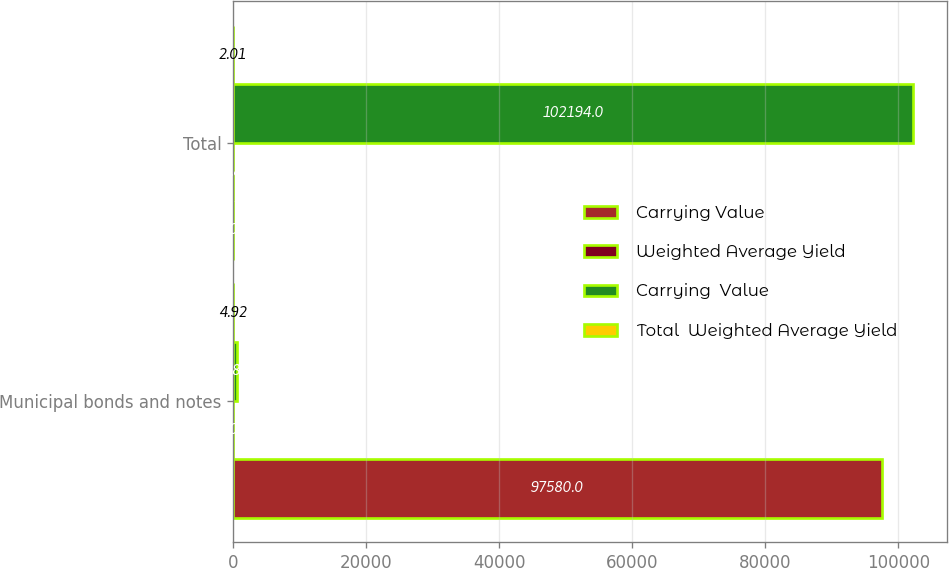Convert chart to OTSL. <chart><loc_0><loc_0><loc_500><loc_500><stacked_bar_chart><ecel><fcel>Municipal bonds and notes<fcel>Total<nl><fcel>Carrying Value<fcel>97580<fcel>6.01<nl><fcel>Weighted Average Yield<fcel>6.01<fcel>1.8<nl><fcel>Carrying  Value<fcel>558<fcel>102194<nl><fcel>Total  Weighted Average Yield<fcel>4.92<fcel>2.01<nl></chart> 